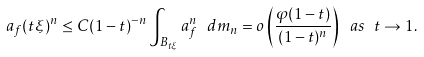Convert formula to latex. <formula><loc_0><loc_0><loc_500><loc_500>a _ { f } ( t \xi ) ^ { n } \leq C ( 1 - t ) ^ { - n } \int _ { B _ { t \xi } } a _ { f } ^ { n } \ d m _ { n } = o \left ( \frac { \varphi ( 1 - t ) } { ( 1 - t ) ^ { n } } \right ) \ a s \ t \to 1 .</formula> 